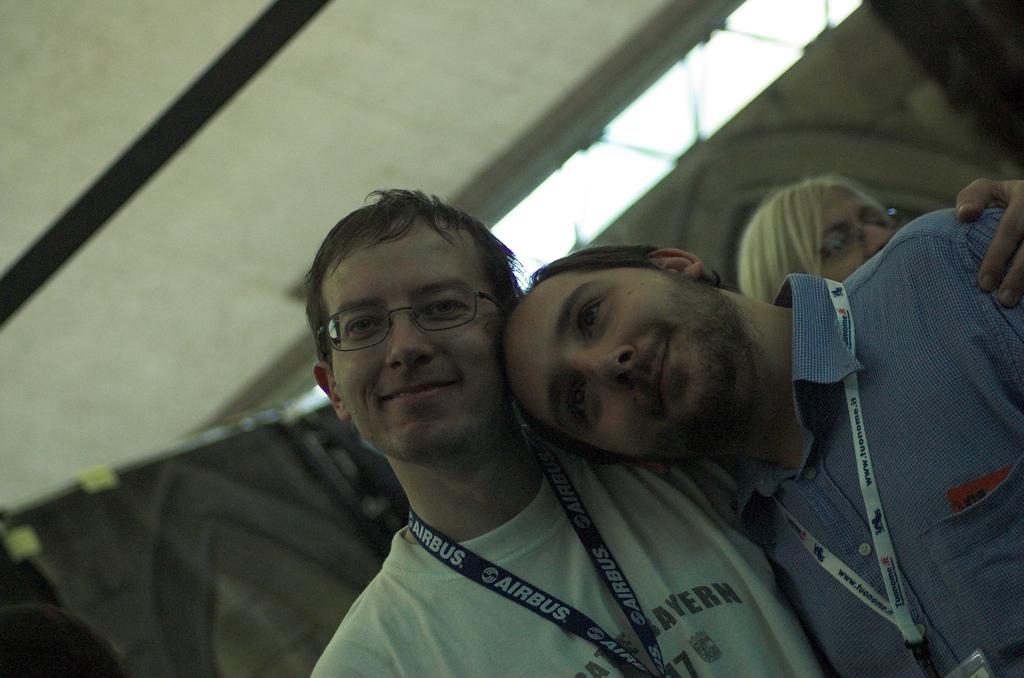How many people are in the image? There are people in the image, specifically two men in front. What are the expressions on the faces of the two men? The two men are smiling in the image. What are the men wearing that identifies them? The two men are wearing ID cards in the image. Can you describe the background of the image? The background of the image is blurred. What type of waves can be seen crashing on the shore in the image? There are no waves or shore visible in the image; it features two men smiling and wearing ID cards. What kind of waste is being disposed of in the image? There is no waste or disposal activity depicted in the image. 